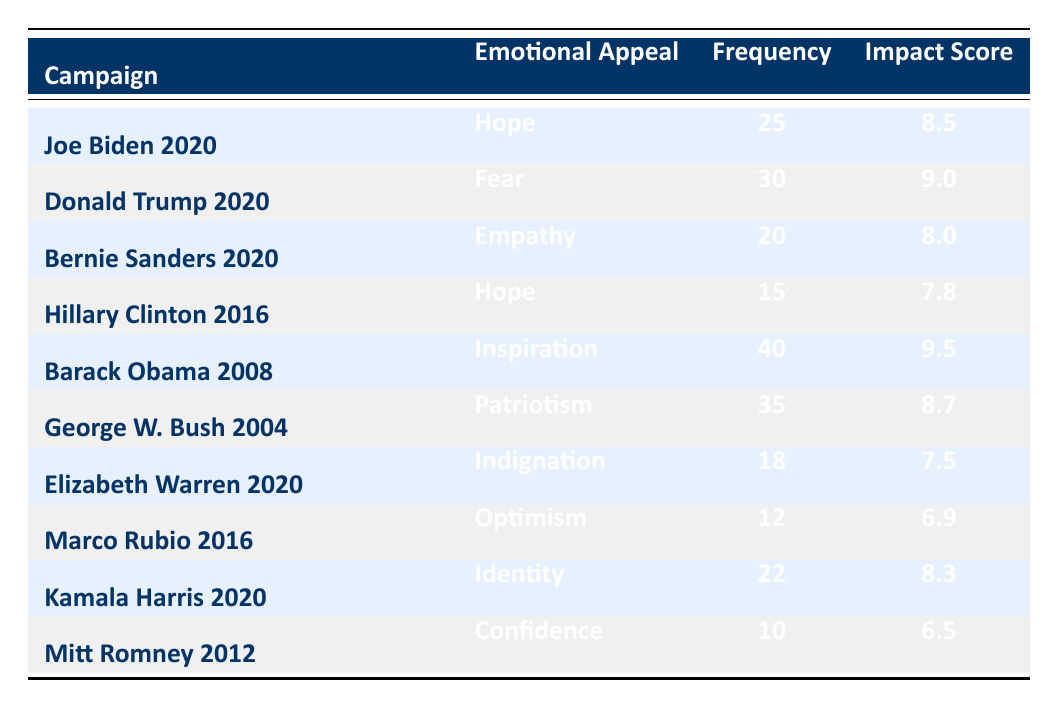What is the emotional appeal used the most frequently in Barack Obama's 2008 campaign? The table shows that the emotional appeal "Inspiration" in Barack Obama's 2008 campaign has a frequency of 40, making it the most frequently used appeal in that campaign.
Answer: Inspiration Which campaign used "Fear" as an emotional appeal, and what was its impact score? The table indicates that "Fear" was used in Donald Trump's 2020 campaign, where it had an impact score of 9.0.
Answer: Donald Trump 2020, 9.0 What is the average frequency of emotional appeals for campaigns that used "Hope"? The two campaigns that used "Hope" are Joe Biden 2020 (25) and Hillary Clinton 2016 (15). To find the average, add their frequencies: 25 + 15 = 40. Then, divide by the number of campaigns using "Hope," which is 2. Therefore, the average frequency is 40 / 2 = 20.
Answer: 20 Is the impact score of "Indignation" higher than that of "Confidence"? The impact score for "Indignation" from Elizabeth Warren 2020 is 7.5, while the impact score for "Confidence" from Mitt Romney 2012 is 6.5. Since 7.5 is greater than 6.5, the statement is true.
Answer: Yes What is the total frequency of emotional appeals used in the campaigns that had an impact score above 8? To answer this, we need to identify the campaigns with an impact score above 8: Barack Obama 2008 (40), Donald Trump 2020 (30), and Joe Biden 2020 (25). Now, add these frequencies: 40 + 30 + 25 = 95. Thus, the total frequency is 95.
Answer: 95 